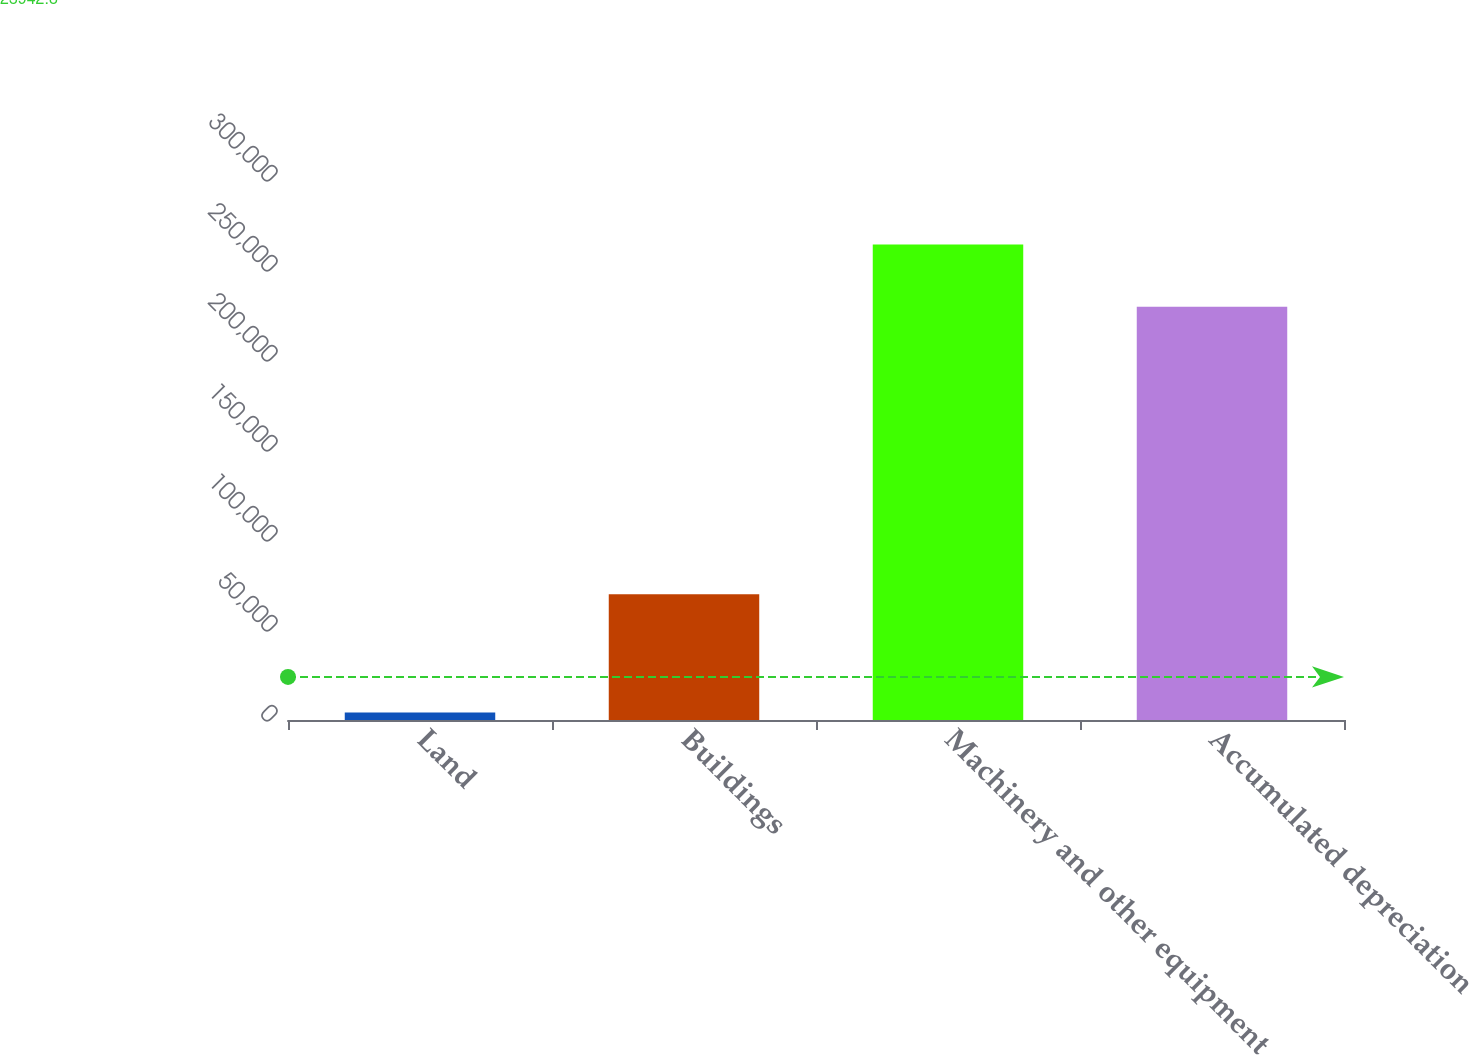<chart> <loc_0><loc_0><loc_500><loc_500><bar_chart><fcel>Land<fcel>Buildings<fcel>Machinery and other equipment<fcel>Accumulated depreciation<nl><fcel>4228<fcel>69871<fcel>264216<fcel>229540<nl></chart> 